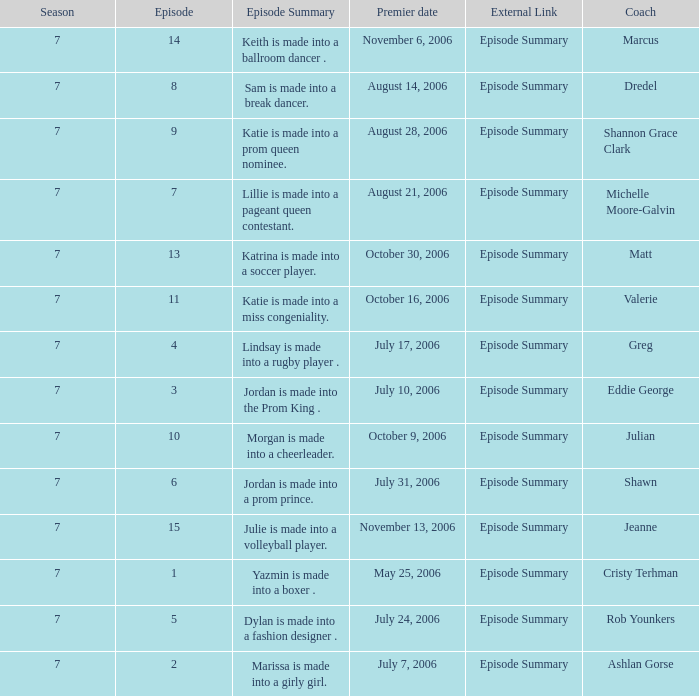What the summary of episode 15? Julie is made into a volleyball player. 